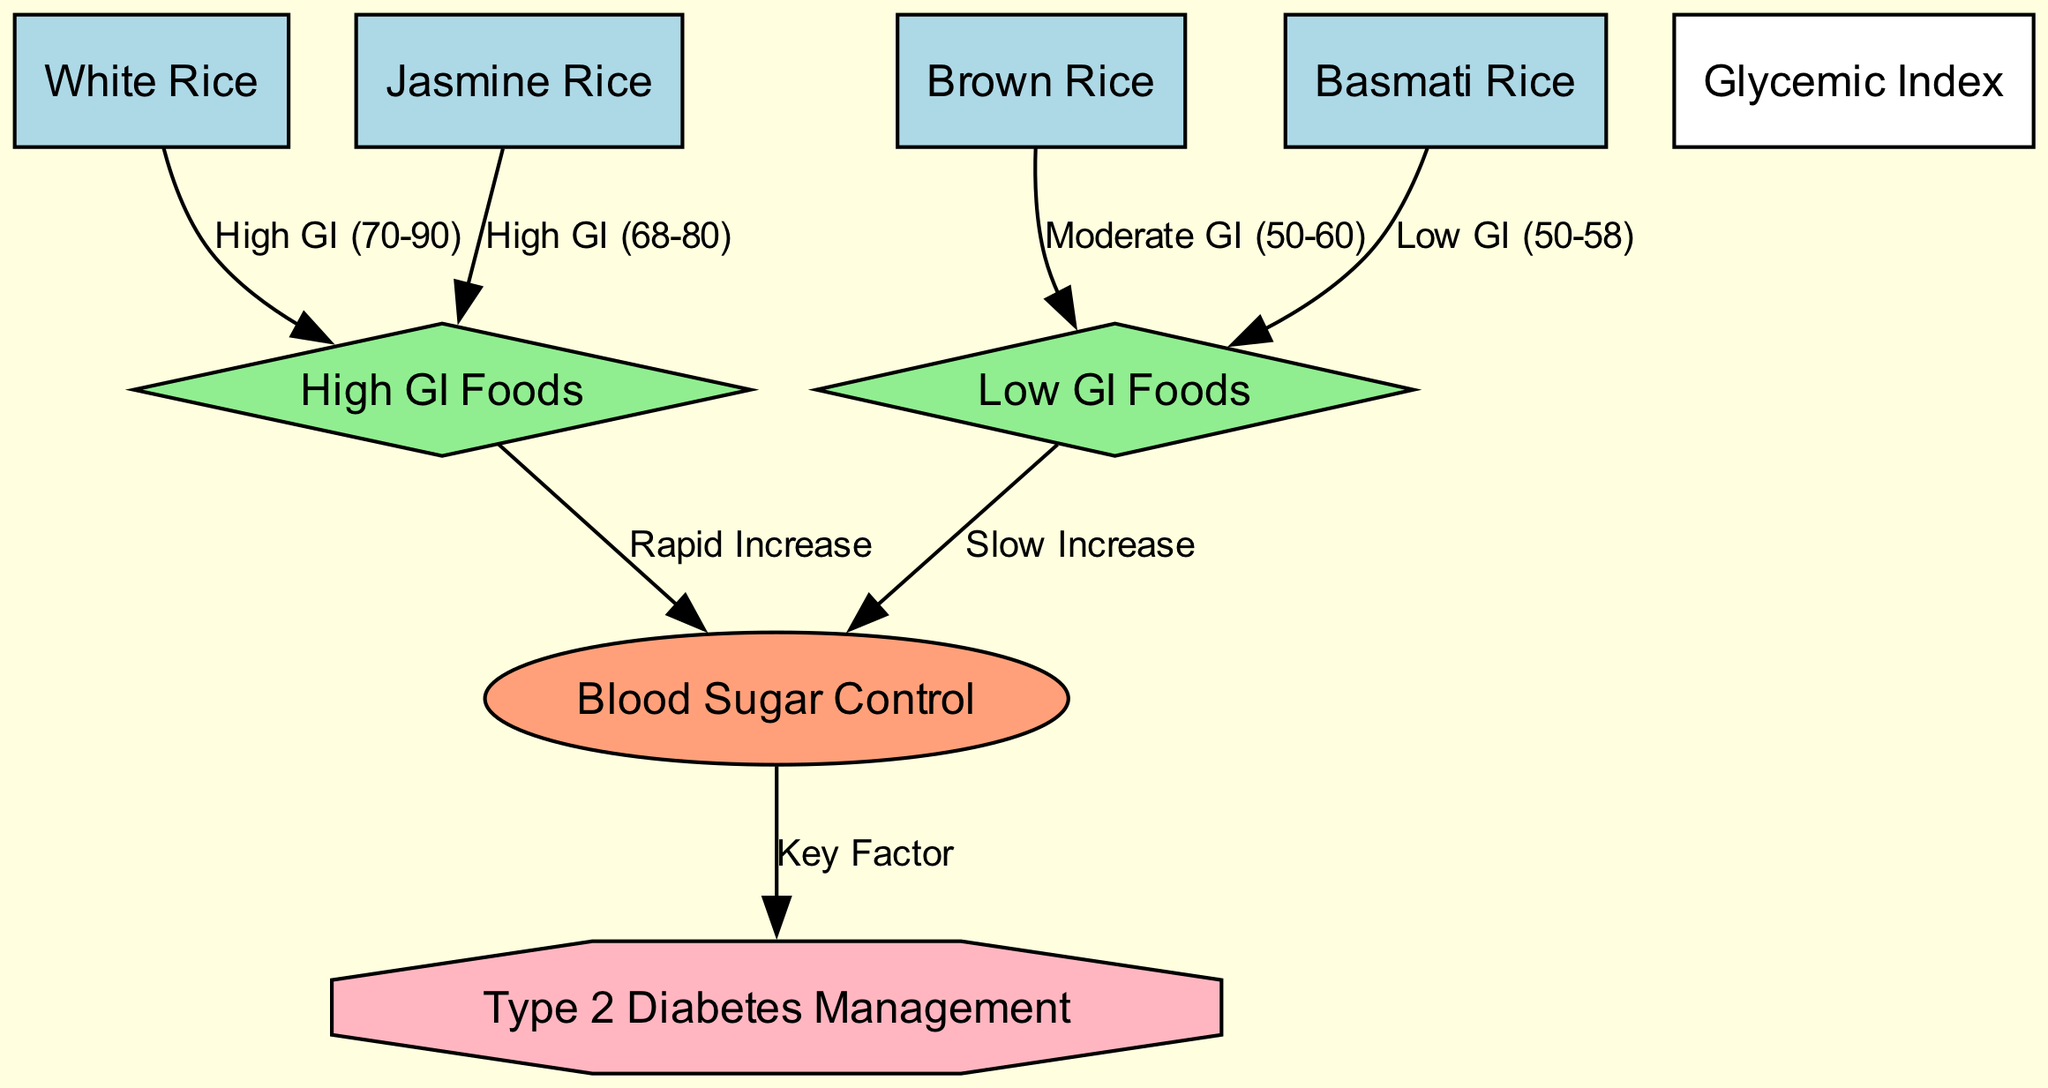What is the glycemic index range for White Rice? The diagram states that White Rice has a glycemic index categorized as High GI, specifically between 70 to 90. This information is directly connected to the node labeled "White Rice."
Answer: High GI (70-90) Which rice variety is associated with Low GI Foods? The diagram connects Brown Rice and Basmati Rice to the "Low GI Foods" category, indicating that both types are recognized for having a low glycemic index.
Answer: Brown Rice, Basmati Rice How many types of rice varieties are represented in the diagram? The diagram displays four distinct rice varieties: White Rice, Brown Rice, Basmati Rice, and Jasmine Rice. By counting these nodes, we establish the total number of varieties.
Answer: 4 What is the effect of High GI Foods on blood sugar control? The diagram illustrates that High GI Foods lead to a "Rapid Increase" in blood sugar control, showing the impact of such foods on glucose levels.
Answer: Rapid Increase What flow connects Low GI Foods to Type 2 Diabetes Management? The diagram indicates that Low GI Foods enhance Blood Sugar Control by causing a "Slow Increase," which is a key factor in the management of Type 2 Diabetes. This demonstrates the positive effect of Low GI Foods on overall diabetes management.
Answer: Slow Increase What key factor influences Type 2 Diabetes Management? According to the diagram, the "Blood Sugar Control" node is identified as a key factor that influences Type 2 Diabetes Management. It highlights the importance of maintaining balanced blood sugar levels in diabetes care.
Answer: Blood Sugar Control Which rice variety falls into the High GI category along with White Rice? The diagram links Jasmine Rice to the High GI Foods category, indicating its similarity in glycemic index classification alongside White Rice.
Answer: Jasmine Rice What is the glycemic index classification for Basmati Rice? The diagram categorizes Basmati Rice as Low GI, with a specific range noted as 50 to 58. This classification reflects its impact on blood sugar levels compared to other rice varieties.
Answer: Low GI (50-58) 